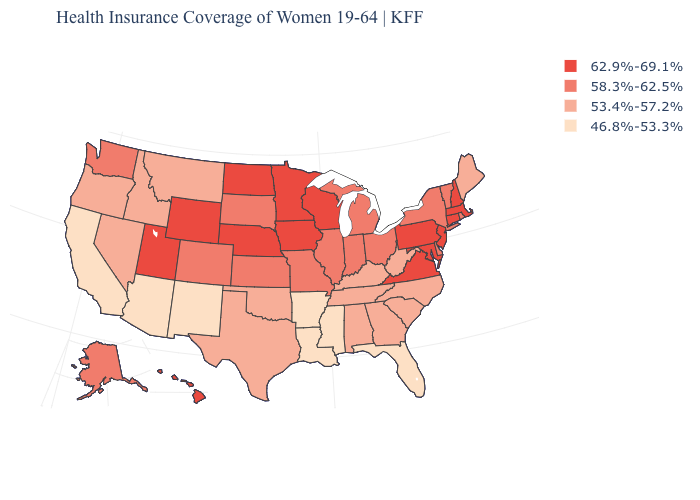What is the lowest value in states that border California?
Write a very short answer. 46.8%-53.3%. Among the states that border Vermont , does New York have the lowest value?
Keep it brief. Yes. Which states have the highest value in the USA?
Write a very short answer. Connecticut, Hawaii, Iowa, Maryland, Massachusetts, Minnesota, Nebraska, New Hampshire, New Jersey, North Dakota, Pennsylvania, Utah, Virginia, Wisconsin, Wyoming. Which states have the lowest value in the South?
Write a very short answer. Arkansas, Florida, Louisiana, Mississippi. What is the value of Louisiana?
Quick response, please. 46.8%-53.3%. What is the lowest value in the USA?
Short answer required. 46.8%-53.3%. Which states have the lowest value in the West?
Be succinct. Arizona, California, New Mexico. Which states have the lowest value in the USA?
Quick response, please. Arizona, Arkansas, California, Florida, Louisiana, Mississippi, New Mexico. Does New Mexico have a higher value than Michigan?
Answer briefly. No. What is the highest value in the Northeast ?
Write a very short answer. 62.9%-69.1%. Among the states that border Colorado , which have the highest value?
Be succinct. Nebraska, Utah, Wyoming. What is the value of Michigan?
Give a very brief answer. 58.3%-62.5%. What is the value of Vermont?
Keep it brief. 58.3%-62.5%. Name the states that have a value in the range 46.8%-53.3%?
Answer briefly. Arizona, Arkansas, California, Florida, Louisiana, Mississippi, New Mexico. Does the map have missing data?
Keep it brief. No. 